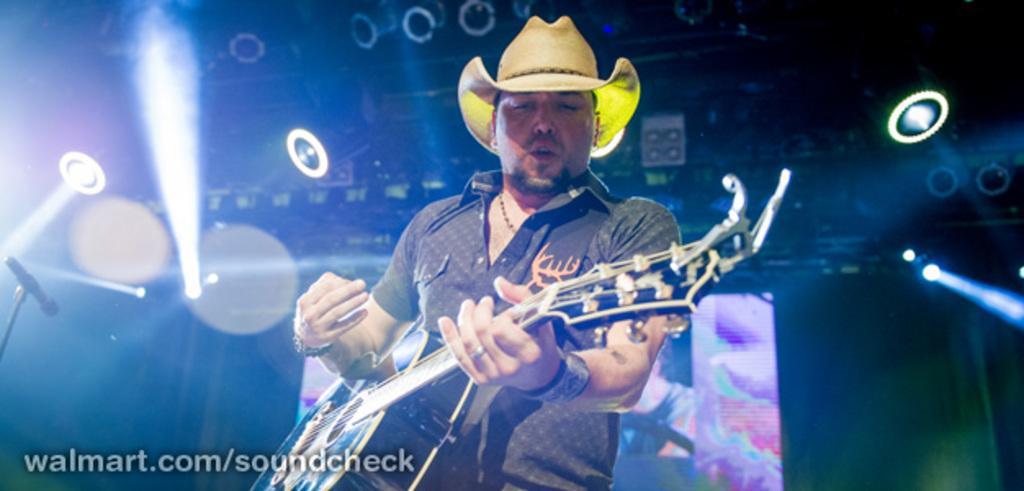Can you describe this image briefly? In this image i can see a person standing and holding a guitar. In the background i can see few lights and a microphone. 